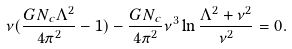<formula> <loc_0><loc_0><loc_500><loc_500>\nu ( \frac { G N _ { c } \Lambda ^ { 2 } } { 4 \pi ^ { 2 } } - 1 ) - \frac { G N _ { c } } { 4 \pi ^ { 2 } } \nu ^ { 3 } \ln \frac { \Lambda ^ { 2 } + \nu ^ { 2 } } { \nu ^ { 2 } } = 0 .</formula> 